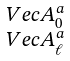<formula> <loc_0><loc_0><loc_500><loc_500>\begin{smallmatrix} \ V e c { A } _ { 0 } ^ { a } \\ \ V e c { A } _ { \ell } ^ { a } \end{smallmatrix}</formula> 